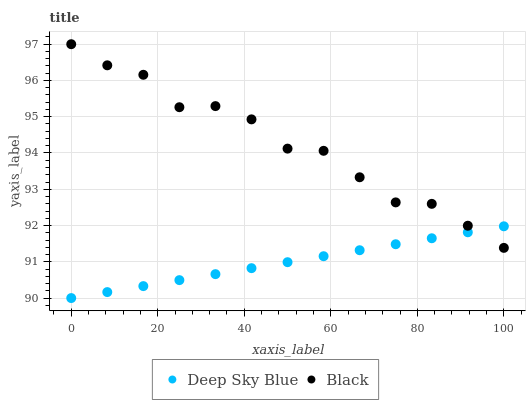Does Deep Sky Blue have the minimum area under the curve?
Answer yes or no. Yes. Does Black have the maximum area under the curve?
Answer yes or no. Yes. Does Deep Sky Blue have the maximum area under the curve?
Answer yes or no. No. Is Deep Sky Blue the smoothest?
Answer yes or no. Yes. Is Black the roughest?
Answer yes or no. Yes. Is Deep Sky Blue the roughest?
Answer yes or no. No. Does Deep Sky Blue have the lowest value?
Answer yes or no. Yes. Does Black have the highest value?
Answer yes or no. Yes. Does Deep Sky Blue have the highest value?
Answer yes or no. No. Does Deep Sky Blue intersect Black?
Answer yes or no. Yes. Is Deep Sky Blue less than Black?
Answer yes or no. No. Is Deep Sky Blue greater than Black?
Answer yes or no. No. 